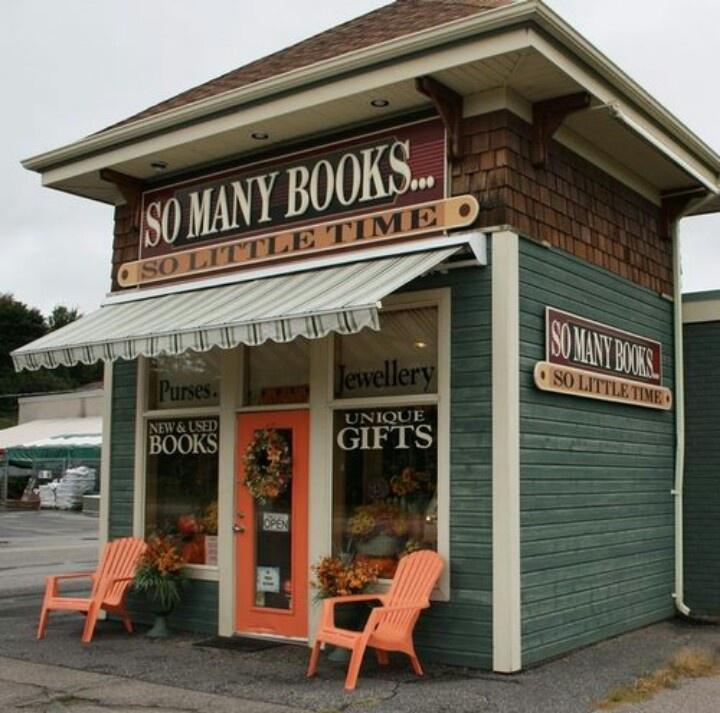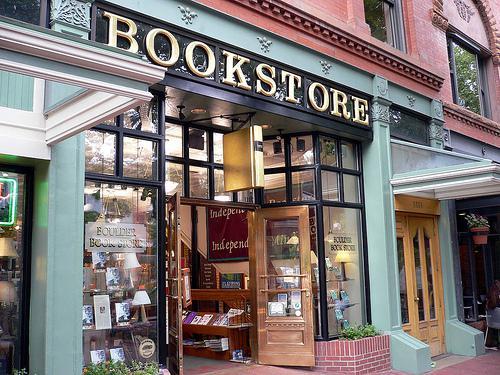The first image is the image on the left, the second image is the image on the right. Analyze the images presented: Is the assertion "The exterior of a book shop includes some type of outdoor seating furniture." valid? Answer yes or no. Yes. The first image is the image on the left, the second image is the image on the right. Considering the images on both sides, is "A form of seating is shown outside of a bookstore." valid? Answer yes or no. Yes. 